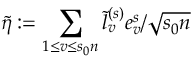<formula> <loc_0><loc_0><loc_500><loc_500>\tilde { \eta } \colon = \sum _ { 1 \leq v \leq s _ { 0 } n } \tilde { l } _ { v } ^ { ( s ) } e _ { v } ^ { s } / \sqrt { s _ { 0 } n }</formula> 